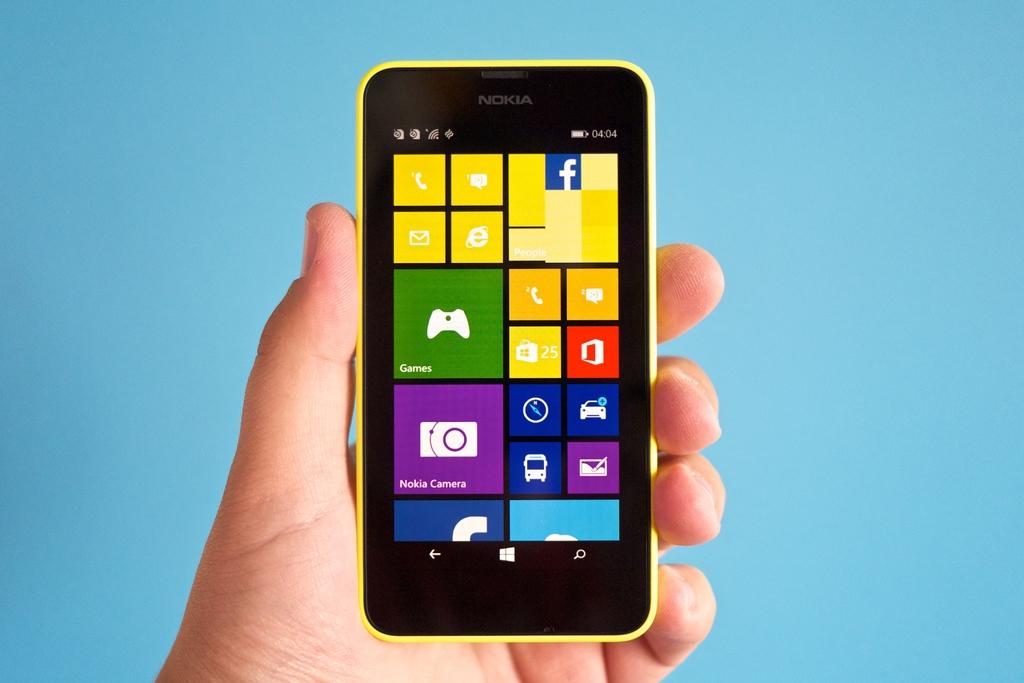What brand is this phone?
Provide a succinct answer. Nokia. 